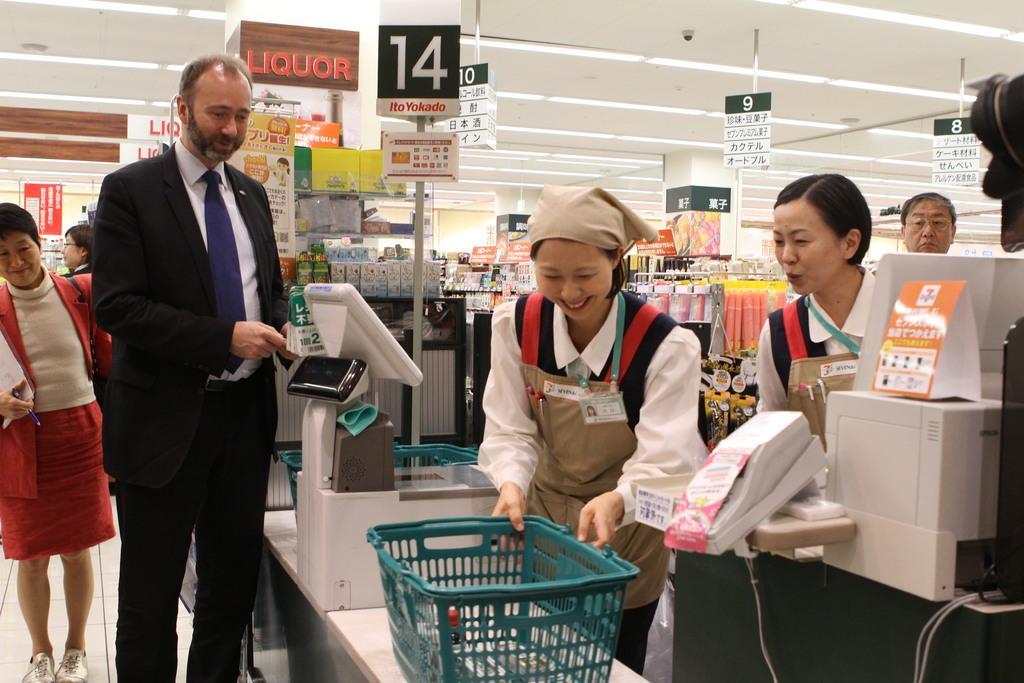Could you give a brief overview of what you see in this image? In this image I can see inside view of a store and in the front I can see few people are standing. I can also see few trolleys and few machines. In the background I can see number of stuffs, number of boards, number of lights and on these boards I can see something is written. I can also see a CCTV camera on the top side of this image. 